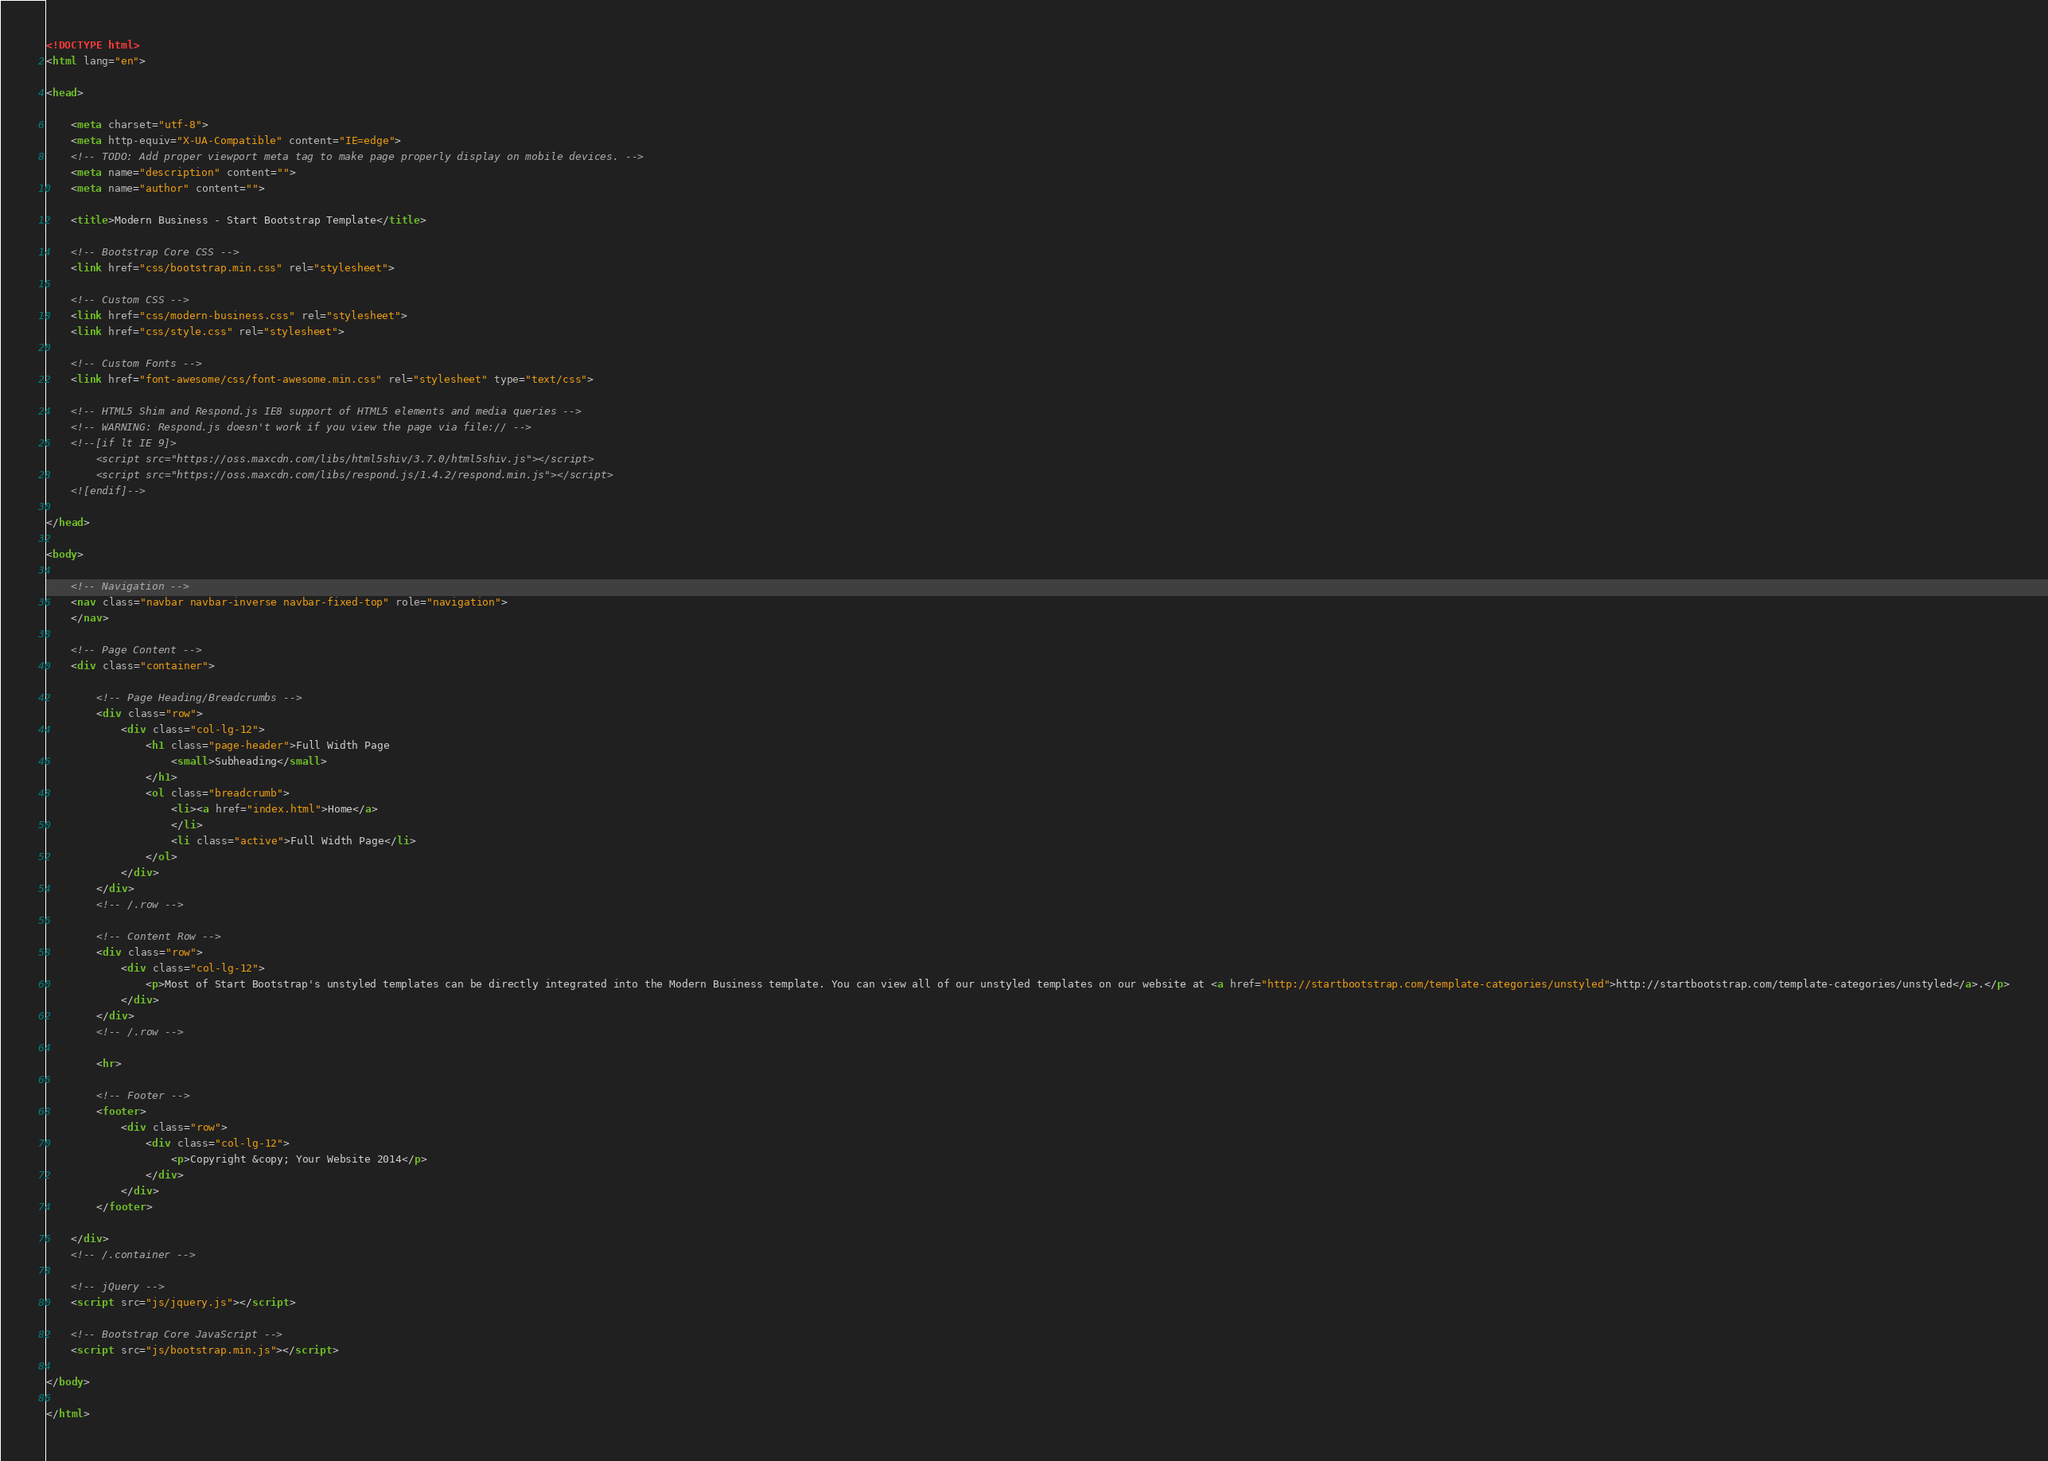<code> <loc_0><loc_0><loc_500><loc_500><_HTML_><!DOCTYPE html>
<html lang="en">

<head>

    <meta charset="utf-8">
    <meta http-equiv="X-UA-Compatible" content="IE=edge">
    <!-- TODO: Add proper viewport meta tag to make page properly display on mobile devices. -->
    <meta name="description" content="">
    <meta name="author" content="">

    <title>Modern Business - Start Bootstrap Template</title>

    <!-- Bootstrap Core CSS -->
    <link href="css/bootstrap.min.css" rel="stylesheet">

    <!-- Custom CSS -->
    <link href="css/modern-business.css" rel="stylesheet">
    <link href="css/style.css" rel="stylesheet">

    <!-- Custom Fonts -->
    <link href="font-awesome/css/font-awesome.min.css" rel="stylesheet" type="text/css">

    <!-- HTML5 Shim and Respond.js IE8 support of HTML5 elements and media queries -->
    <!-- WARNING: Respond.js doesn't work if you view the page via file:// -->
    <!--[if lt IE 9]>
        <script src="https://oss.maxcdn.com/libs/html5shiv/3.7.0/html5shiv.js"></script>
        <script src="https://oss.maxcdn.com/libs/respond.js/1.4.2/respond.min.js"></script>
    <![endif]-->

</head>

<body>

    <!-- Navigation -->
    <nav class="navbar navbar-inverse navbar-fixed-top" role="navigation">
    </nav>

    <!-- Page Content -->
    <div class="container">

        <!-- Page Heading/Breadcrumbs -->
        <div class="row">
            <div class="col-lg-12">
                <h1 class="page-header">Full Width Page
                    <small>Subheading</small>
                </h1>
                <ol class="breadcrumb">
                    <li><a href="index.html">Home</a>
                    </li>
                    <li class="active">Full Width Page</li>
                </ol>
            </div>
        </div>
        <!-- /.row -->

        <!-- Content Row -->
        <div class="row">
            <div class="col-lg-12">
                <p>Most of Start Bootstrap's unstyled templates can be directly integrated into the Modern Business template. You can view all of our unstyled templates on our website at <a href="http://startbootstrap.com/template-categories/unstyled">http://startbootstrap.com/template-categories/unstyled</a>.</p>
            </div>
        </div>
        <!-- /.row -->

        <hr>

        <!-- Footer -->
        <footer>
            <div class="row">
                <div class="col-lg-12">
                    <p>Copyright &copy; Your Website 2014</p>
                </div>
            </div>
        </footer>

    </div>
    <!-- /.container -->

    <!-- jQuery -->
    <script src="js/jquery.js"></script>

    <!-- Bootstrap Core JavaScript -->
    <script src="js/bootstrap.min.js"></script>

</body>

</html>
</code> 